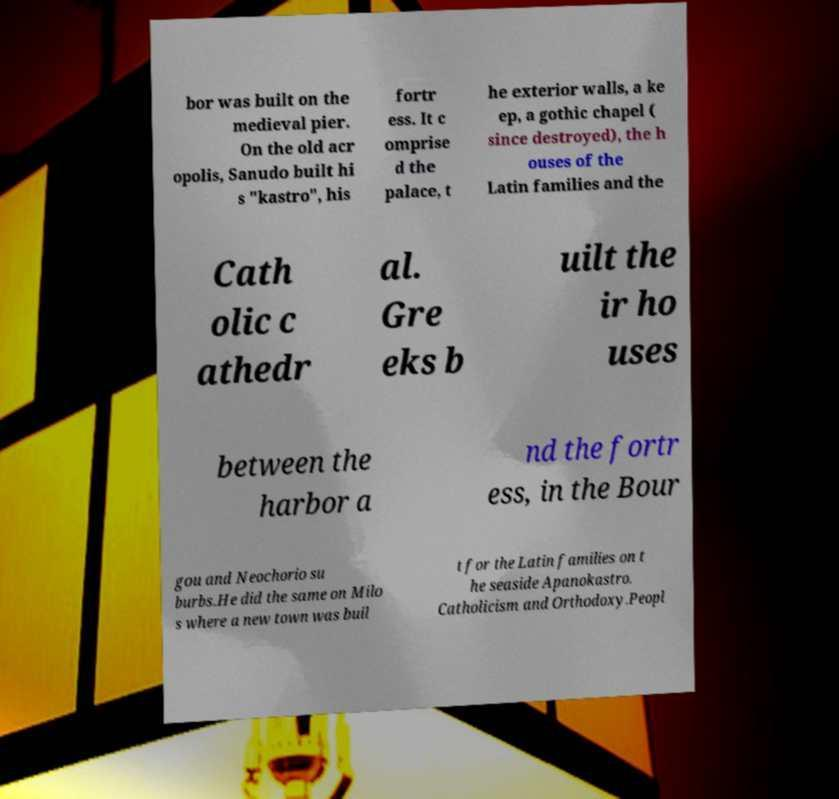Please identify and transcribe the text found in this image. bor was built on the medieval pier. On the old acr opolis, Sanudo built hi s "kastro", his fortr ess. It c omprise d the palace, t he exterior walls, a ke ep, a gothic chapel ( since destroyed), the h ouses of the Latin families and the Cath olic c athedr al. Gre eks b uilt the ir ho uses between the harbor a nd the fortr ess, in the Bour gou and Neochorio su burbs.He did the same on Milo s where a new town was buil t for the Latin families on t he seaside Apanokastro. Catholicism and Orthodoxy.Peopl 